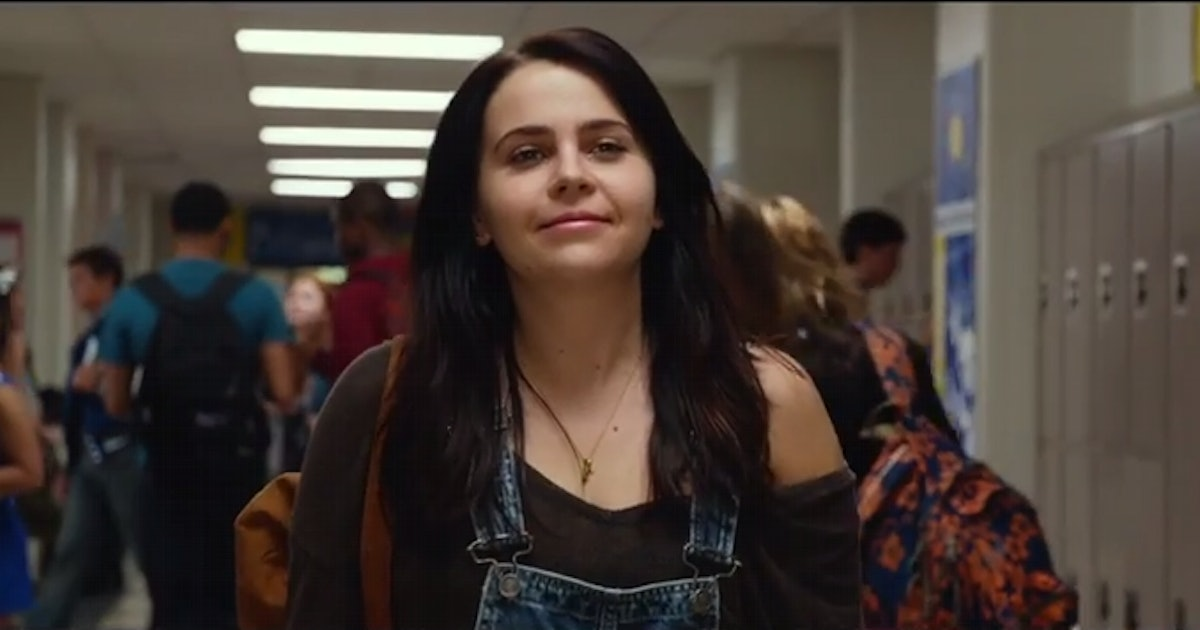Describe the scenario depicted in this image. In this image, a character is walking down a high school hallway filled with students. She is carrying a backpack over one shoulder and is dressed casually in a brown cardigan over a black tank top and blue overalls. The hallway is busy with other students, all heading in the opposite direction, possibly indicating a change of classes. The setting appears to capture a typical day in a high school. 